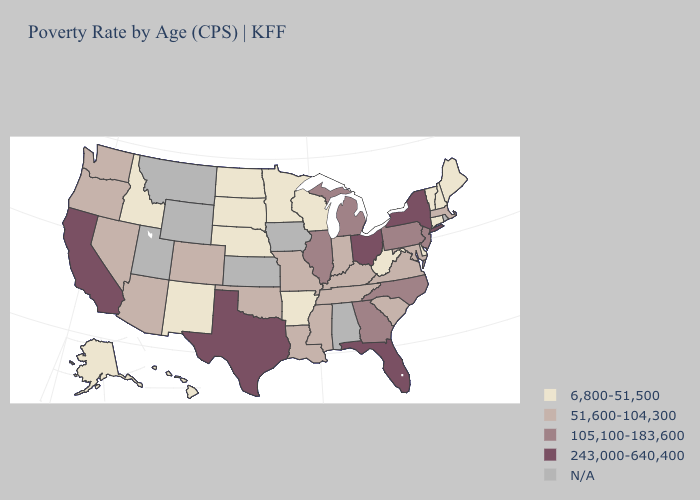What is the value of Vermont?
Write a very short answer. 6,800-51,500. What is the lowest value in the South?
Be succinct. 6,800-51,500. Name the states that have a value in the range 105,100-183,600?
Keep it brief. Georgia, Illinois, Michigan, New Jersey, North Carolina, Pennsylvania. What is the lowest value in states that border Alabama?
Be succinct. 51,600-104,300. Is the legend a continuous bar?
Give a very brief answer. No. What is the highest value in states that border Missouri?
Keep it brief. 105,100-183,600. What is the value of Vermont?
Write a very short answer. 6,800-51,500. What is the highest value in the West ?
Short answer required. 243,000-640,400. Does Indiana have the highest value in the USA?
Write a very short answer. No. Name the states that have a value in the range 243,000-640,400?
Quick response, please. California, Florida, New York, Ohio, Texas. Name the states that have a value in the range N/A?
Short answer required. Alabama, Iowa, Kansas, Montana, Rhode Island, Utah, Wyoming. What is the highest value in states that border Pennsylvania?
Keep it brief. 243,000-640,400. What is the value of Louisiana?
Keep it brief. 51,600-104,300. Does New York have the highest value in the USA?
Short answer required. Yes. Does California have the highest value in the USA?
Quick response, please. Yes. 